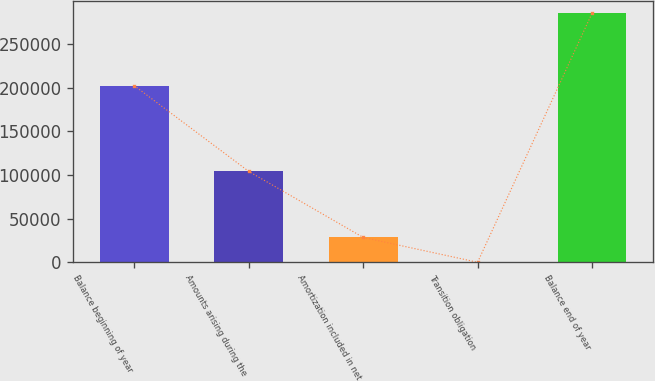<chart> <loc_0><loc_0><loc_500><loc_500><bar_chart><fcel>Balance beginning of year<fcel>Amounts arising during the<fcel>Amortization included in net<fcel>Transition obligation<fcel>Balance end of year<nl><fcel>202292<fcel>104146<fcel>28522.2<fcel>5<fcel>285177<nl></chart> 